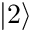<formula> <loc_0><loc_0><loc_500><loc_500>\left | 2 \right \rangle</formula> 